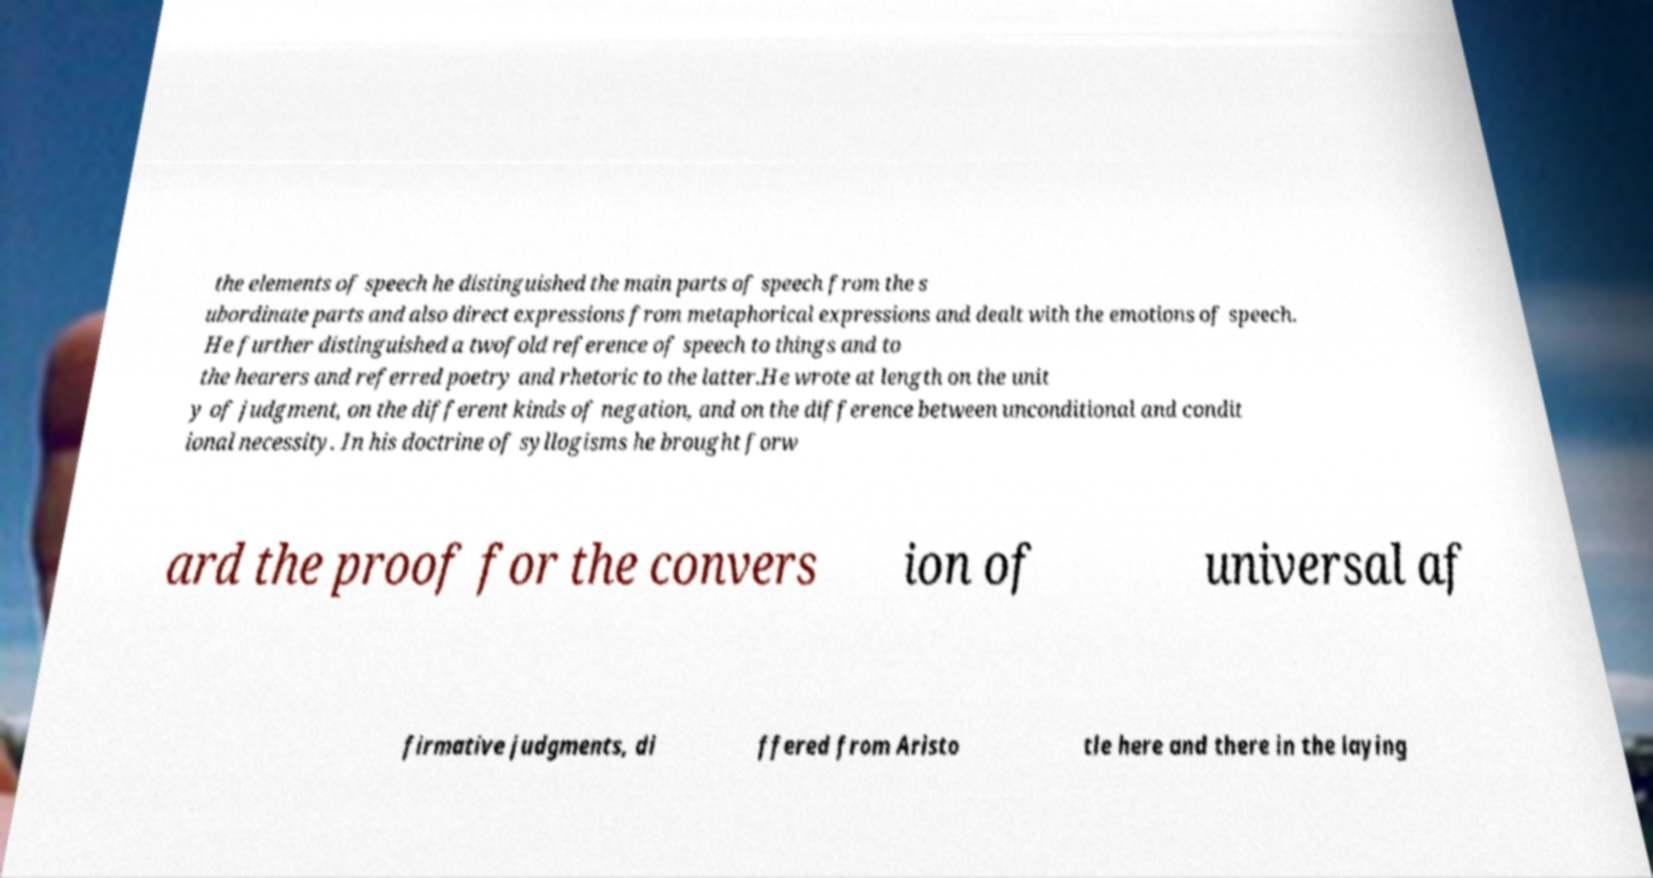There's text embedded in this image that I need extracted. Can you transcribe it verbatim? the elements of speech he distinguished the main parts of speech from the s ubordinate parts and also direct expressions from metaphorical expressions and dealt with the emotions of speech. He further distinguished a twofold reference of speech to things and to the hearers and referred poetry and rhetoric to the latter.He wrote at length on the unit y of judgment, on the different kinds of negation, and on the difference between unconditional and condit ional necessity. In his doctrine of syllogisms he brought forw ard the proof for the convers ion of universal af firmative judgments, di ffered from Aristo tle here and there in the laying 